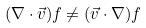<formula> <loc_0><loc_0><loc_500><loc_500>( \nabla \cdot \vec { v } ) f \ne ( \vec { v } \cdot \nabla ) f</formula> 